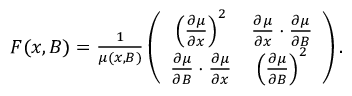Convert formula to latex. <formula><loc_0><loc_0><loc_500><loc_500>\begin{array} { r } { F ( x , B ) = \frac { 1 } { \mu ( x , B ) } \left ( \begin{array} { c c } { \left ( \frac { \partial \mu } { \partial x } \right ) ^ { 2 } } & { \frac { \partial \mu } { \partial x } \cdot \frac { \partial \mu } { \partial B } } \\ { \frac { \partial \mu } { \partial B } \cdot \frac { \partial \mu } { \partial x } } & { \left ( \frac { \partial \mu } { \partial B } \right ) ^ { 2 } } \end{array} \right ) . } \end{array}</formula> 